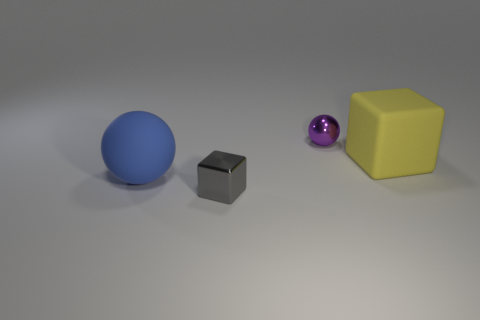Add 2 small purple spheres. How many objects exist? 6 Add 3 big blue matte objects. How many big blue matte objects are left? 4 Add 4 metallic cubes. How many metallic cubes exist? 5 Subtract 0 gray cylinders. How many objects are left? 4 Subtract all rubber balls. Subtract all tiny yellow metal objects. How many objects are left? 3 